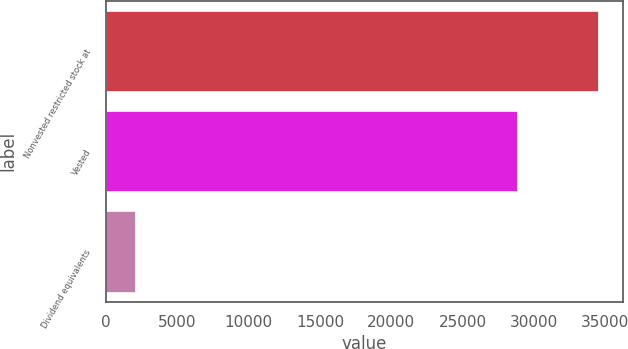<chart> <loc_0><loc_0><loc_500><loc_500><bar_chart><fcel>Nonvested restricted stock at<fcel>Vested<fcel>Dividend equivalents<nl><fcel>34515.6<fcel>28830<fcel>1990<nl></chart> 